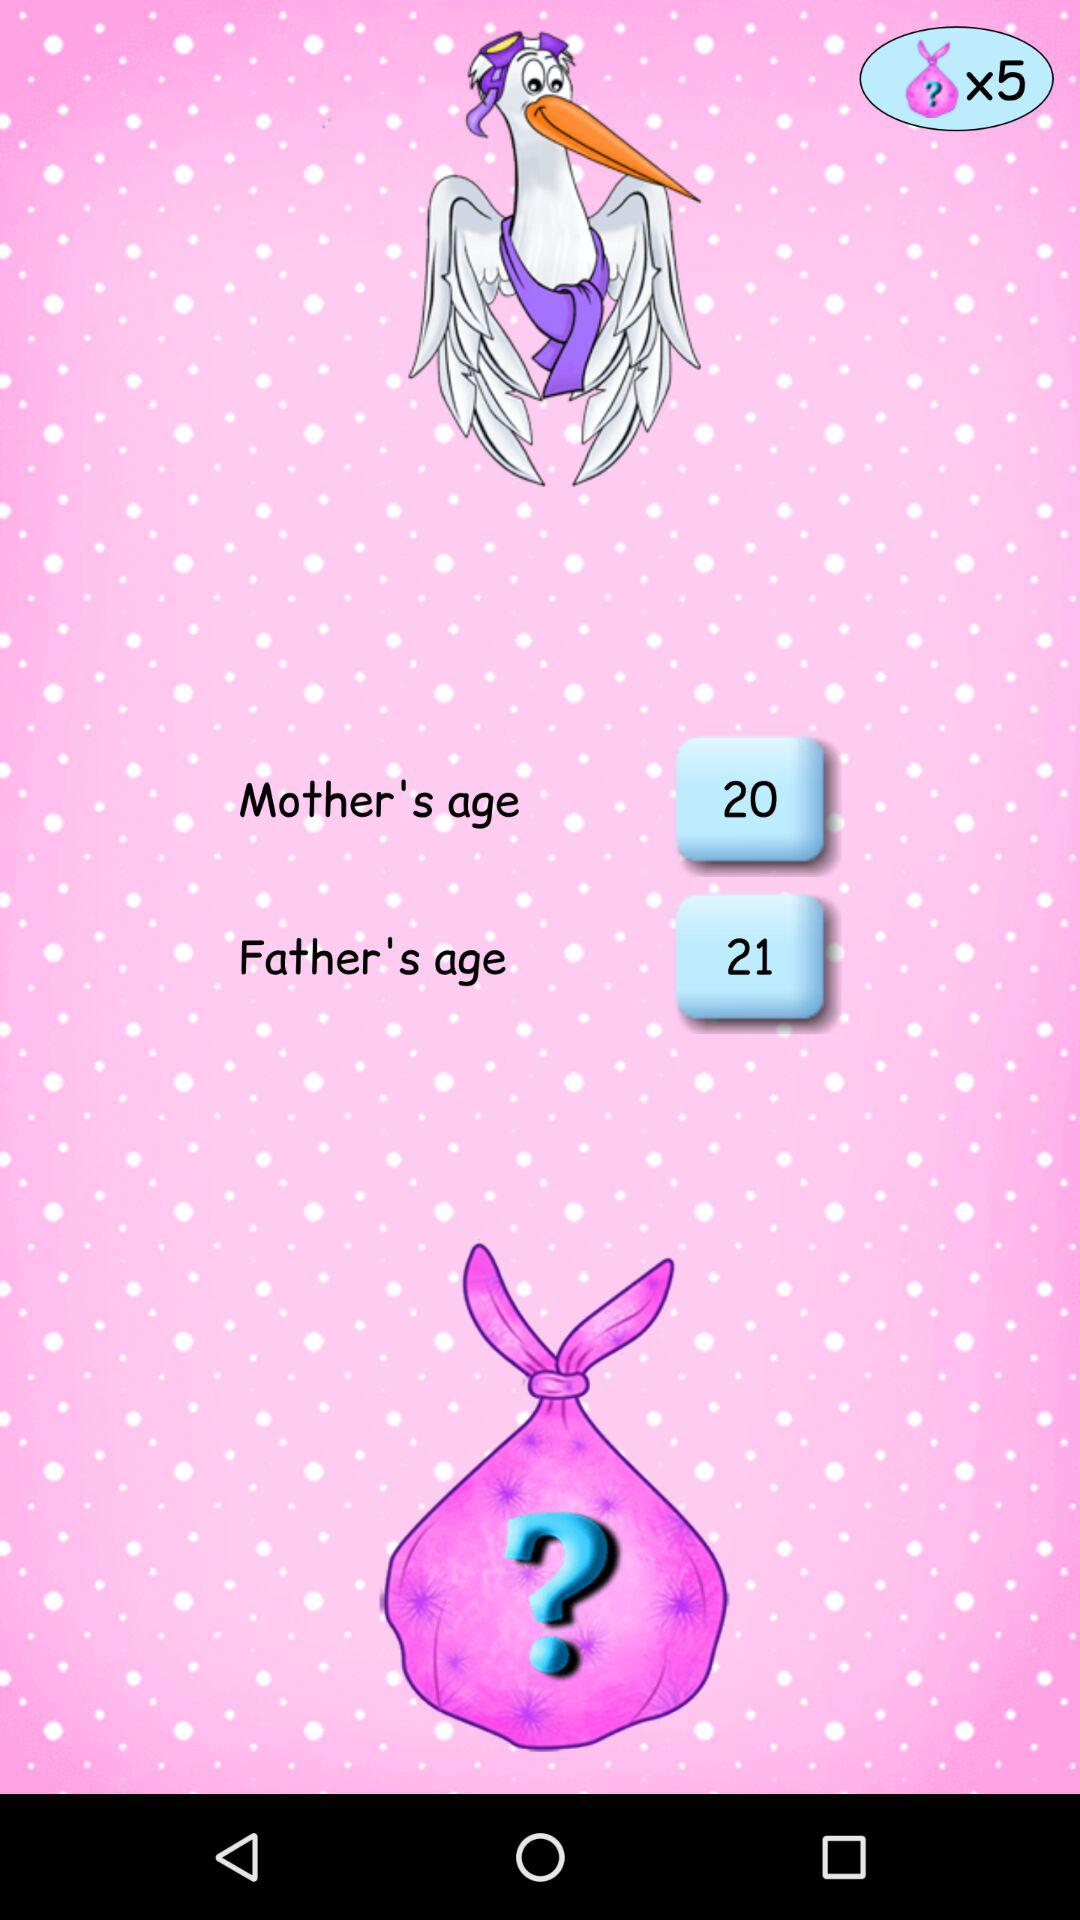Which gender is selected?
When the provided information is insufficient, respond with <no answer>. <no answer> 